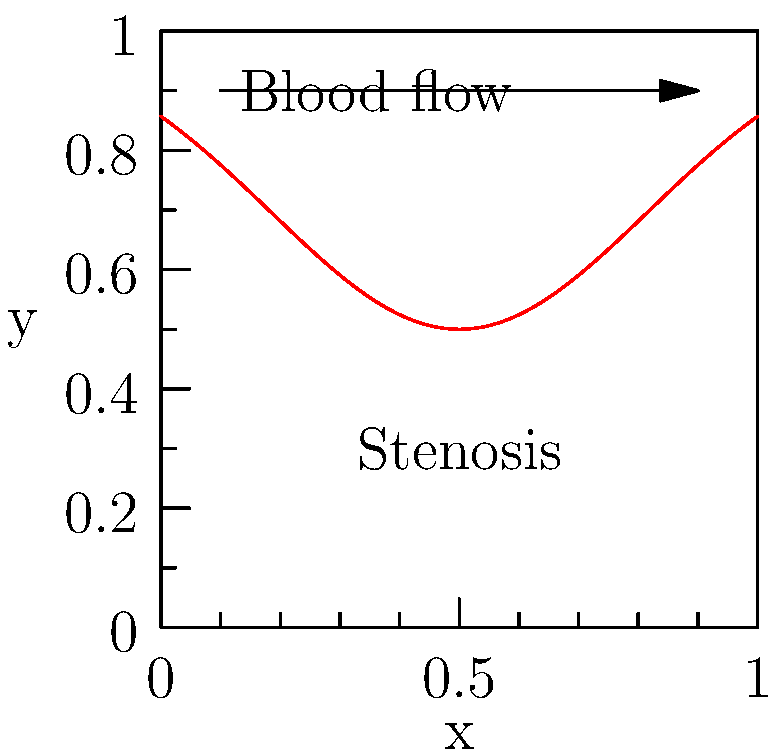Given a computational fluid dynamics (CFD) model of blood flow through an artery with a stenosis, as shown in the figure, how would you modify the Navier-Stokes equations to account for the non-Newtonian behavior of blood? Assume the blood follows the Carreau-Yasuda model. Write the modified momentum equation. To account for the non-Newtonian behavior of blood using the Carreau-Yasuda model in a CFD simulation, we need to modify the Navier-Stokes equations. Here's a step-by-step explanation:

1. Recall the standard Navier-Stokes momentum equation for incompressible flow:

   $$\rho \frac{D\mathbf{u}}{Dt} = -\nabla p + \nabla \cdot (\mu \nabla \mathbf{u}) + \mathbf{f}$$

   where $\rho$ is density, $\mathbf{u}$ is velocity, $p$ is pressure, $\mu$ is dynamic viscosity, and $\mathbf{f}$ represents body forces.

2. For non-Newtonian fluids, the viscosity $\mu$ is not constant but depends on the shear rate. The Carreau-Yasuda model describes this relationship as:

   $$\mu = \mu_{\infty} + (\mu_0 - \mu_{\infty})[1 + (\lambda \dot{\gamma})^a]^{\frac{n-1}{a}}$$

   where $\mu_{\infty}$ is the infinite shear viscosity, $\mu_0$ is the zero shear viscosity, $\lambda$ is the relaxation time, $\dot{\gamma}$ is the shear rate, $a$ is a dimensionless parameter, and $n$ is the power-law index.

3. The shear rate $\dot{\gamma}$ can be expressed in terms of the velocity gradient tensor:

   $$\dot{\gamma} = \sqrt{2\mathbf{D}:\mathbf{D}}$$

   where $\mathbf{D} = \frac{1}{2}[\nabla \mathbf{u} + (\nabla \mathbf{u})^T]$ is the rate-of-deformation tensor.

4. Substitute the Carreau-Yasuda model for $\mu$ into the Navier-Stokes momentum equation:

   $$\rho \frac{D\mathbf{u}}{Dt} = -\nabla p + \nabla \cdot \left\{[\mu_{\infty} + (\mu_0 - \mu_{\infty})(1 + (\lambda \dot{\gamma})^a)^{\frac{n-1}{a}}] \nabla \mathbf{u}\right\} + \mathbf{f}$$

This modified equation now accounts for the non-Newtonian behavior of blood using the Carreau-Yasuda model.
Answer: $$\rho \frac{D\mathbf{u}}{Dt} = -\nabla p + \nabla \cdot \left\{[\mu_{\infty} + (\mu_0 - \mu_{\infty})(1 + (\lambda \dot{\gamma})^a)^{\frac{n-1}{a}}] \nabla \mathbf{u}\right\} + \mathbf{f}$$ 